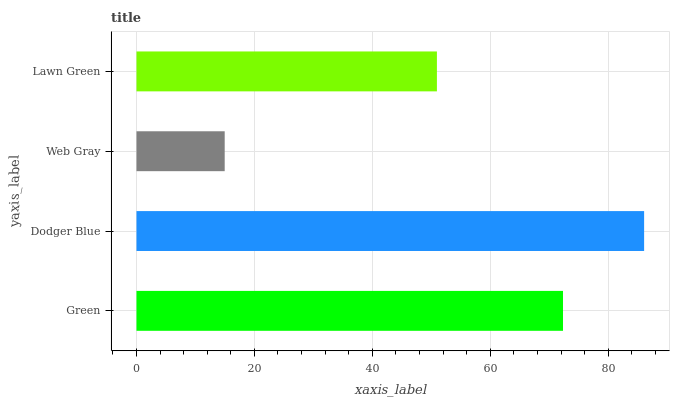Is Web Gray the minimum?
Answer yes or no. Yes. Is Dodger Blue the maximum?
Answer yes or no. Yes. Is Dodger Blue the minimum?
Answer yes or no. No. Is Web Gray the maximum?
Answer yes or no. No. Is Dodger Blue greater than Web Gray?
Answer yes or no. Yes. Is Web Gray less than Dodger Blue?
Answer yes or no. Yes. Is Web Gray greater than Dodger Blue?
Answer yes or no. No. Is Dodger Blue less than Web Gray?
Answer yes or no. No. Is Green the high median?
Answer yes or no. Yes. Is Lawn Green the low median?
Answer yes or no. Yes. Is Dodger Blue the high median?
Answer yes or no. No. Is Green the low median?
Answer yes or no. No. 